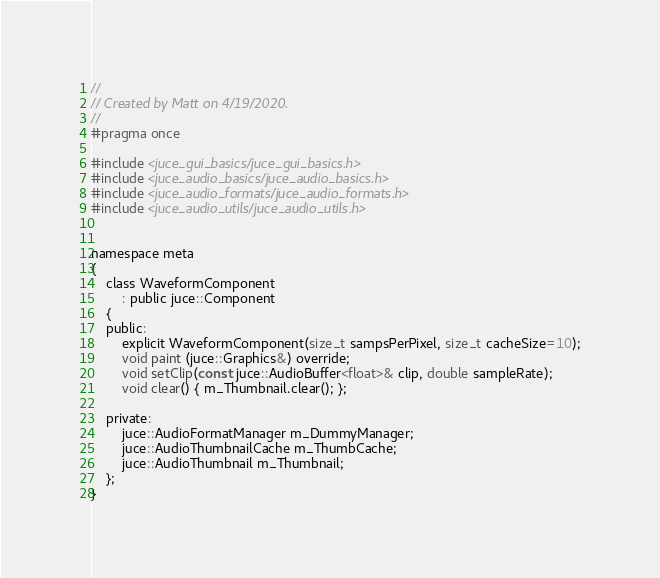<code> <loc_0><loc_0><loc_500><loc_500><_C_>//
// Created by Matt on 4/19/2020.
//
#pragma once

#include <juce_gui_basics/juce_gui_basics.h>
#include <juce_audio_basics/juce_audio_basics.h>
#include <juce_audio_formats/juce_audio_formats.h>
#include <juce_audio_utils/juce_audio_utils.h>


namespace meta
{
    class WaveformComponent
        : public juce::Component
    {
    public:
        explicit WaveformComponent(size_t sampsPerPixel, size_t cacheSize=10);
        void paint (juce::Graphics&) override;
        void setClip(const juce::AudioBuffer<float>& clip, double sampleRate);
        void clear() { m_Thumbnail.clear(); };

    private:
        juce::AudioFormatManager m_DummyManager;
        juce::AudioThumbnailCache m_ThumbCache;
        juce::AudioThumbnail m_Thumbnail;
    };
}
</code> 